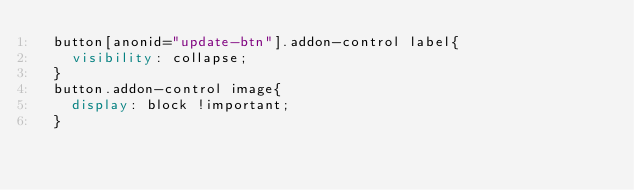Convert code to text. <code><loc_0><loc_0><loc_500><loc_500><_CSS_>	button[anonid="update-btn"].addon-control label{
	  visibility: collapse;
	}
	button.addon-control image{
	  display: block !important;
	}
	</code> 